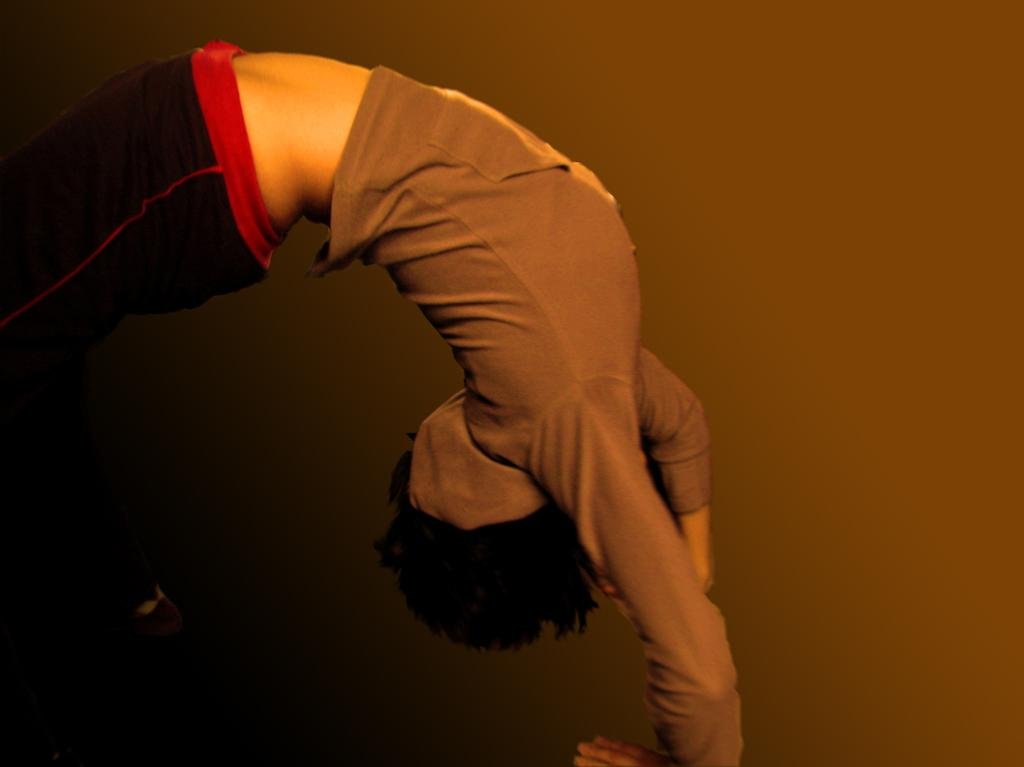What is happening in the image? There is a person in the image, and they are doing gymnastics. Can you describe the person's activity in more detail? The person is performing gymnastics, which typically involves a combination of physical skills, flexibility, and balance. What type of plastic object is being waved by the person in the image? There is no plastic object present in the image; the person is doing gymnastics. What flag is being displayed by the person in the image? There is no flag present in the image; the person is doing gymnastics. 